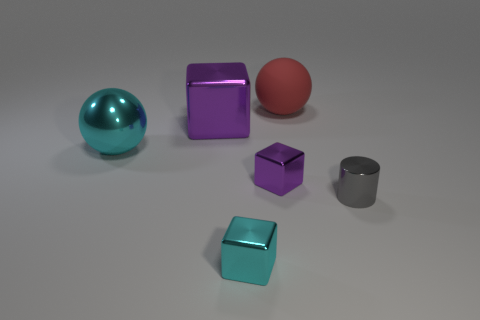What number of things are large spheres that are right of the metallic sphere or large purple metal cylinders?
Make the answer very short. 1. There is a large thing that is the same shape as the tiny purple thing; what is its color?
Provide a short and direct response. Purple. Does the small cyan metal thing have the same shape as the small thing that is to the right of the big red matte object?
Ensure brevity in your answer.  No. What number of objects are cubes behind the small gray metallic cylinder or tiny metal cubes that are behind the small gray thing?
Your answer should be compact. 2. Are there fewer big red things that are in front of the cyan sphere than big red rubber objects?
Make the answer very short. Yes. Do the cyan ball and the big sphere behind the big cyan ball have the same material?
Offer a very short reply. No. What is the material of the big cyan sphere?
Your answer should be very brief. Metal. What material is the tiny cyan object on the left side of the big object that is on the right side of the shiny block that is left of the cyan metal cube made of?
Your answer should be compact. Metal. There is a matte ball; is its color the same as the sphere that is left of the small purple block?
Ensure brevity in your answer.  No. Is there any other thing that is the same shape as the small purple object?
Make the answer very short. Yes. 